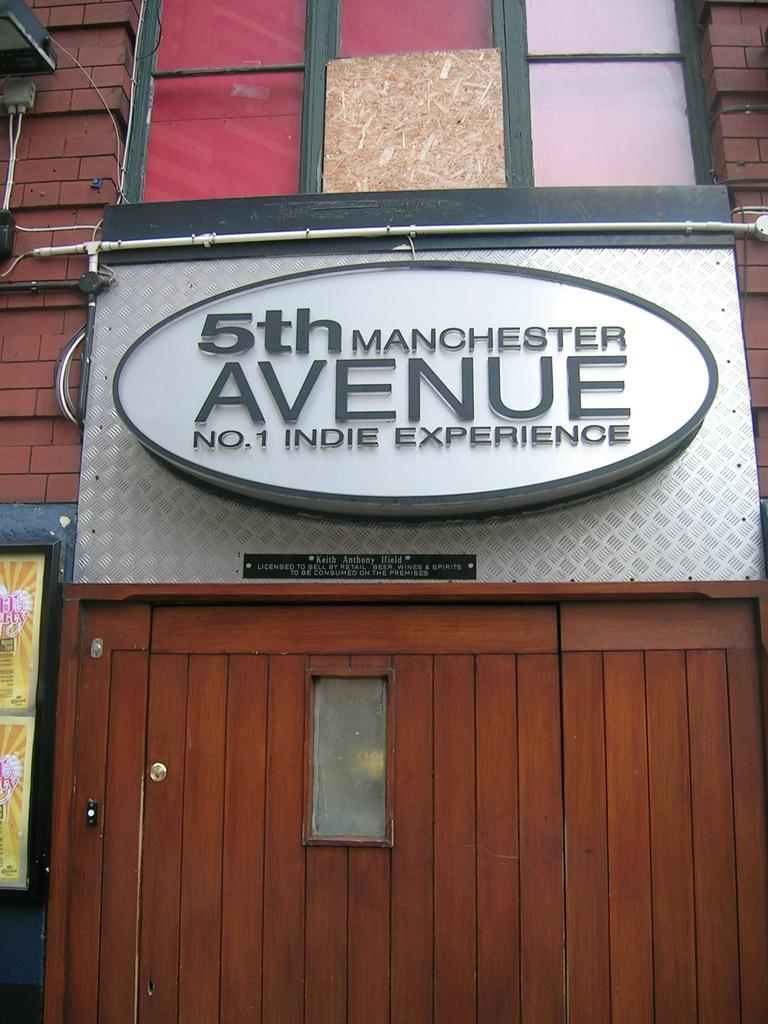What is the main object in the image? There is a board in the image. What is written or displayed on the board? There is text on the board. What type of structure can be seen in the image? The image appears to show a building. Is there any entrance visible in the image? Yes, there is a door visible in the image. How many marbles are rolling on the board in the image? There are no marbles present in the image; it only shows a board with text. What color are the eyes of the person holding the cup in the image? There is no person holding a cup in the image; it only features a board with text and a building with a door. 